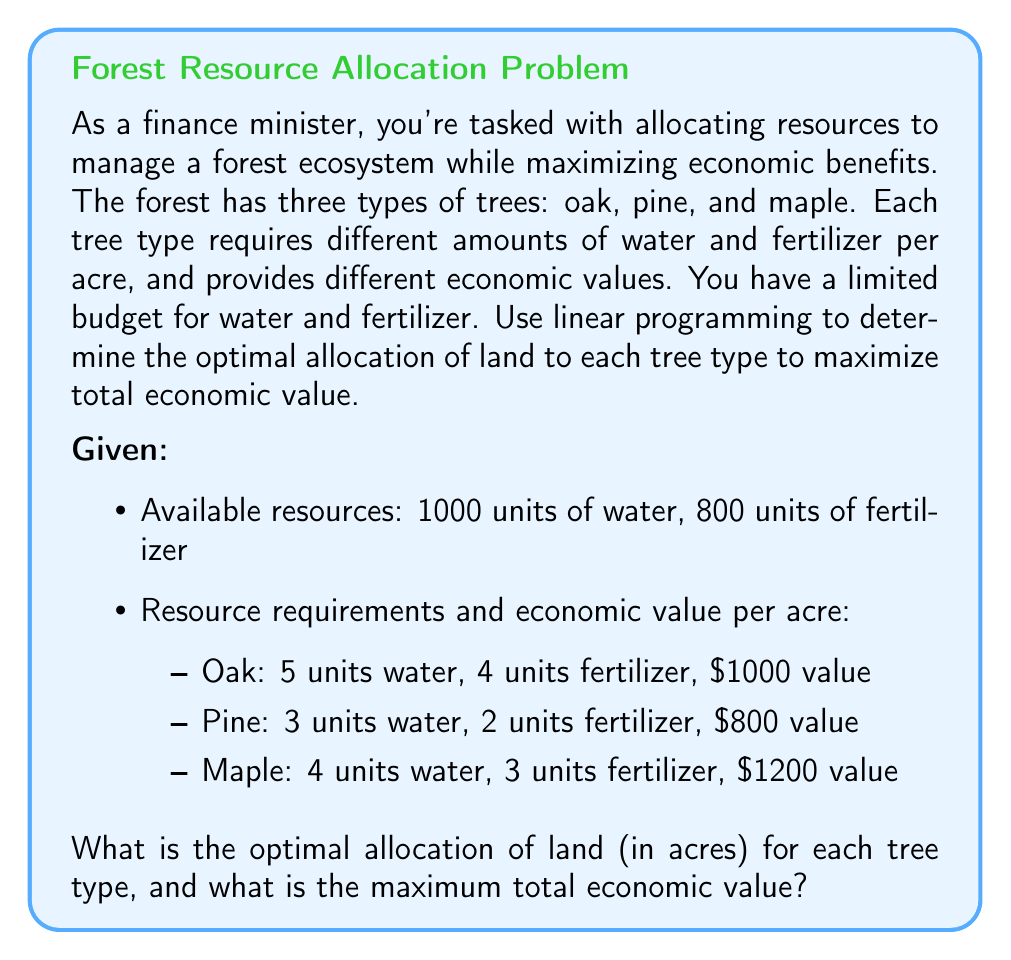Give your solution to this math problem. To solve this linear programming problem, we'll use the simplex method. Let's define our variables and set up the problem:

Let $x$ = acres of oak, $y$ = acres of pine, and $z$ = acres of maple.

Objective function (maximize total value):
$$\text{Max } 1000x + 800y + 1200z$$

Constraints:
1. Water: $5x + 3y + 4z \leq 1000$
2. Fertilizer: $4x + 2y + 3z \leq 800$
3. Non-negativity: $x, y, z \geq 0$

Now, let's solve using the simplex method:

1. Convert to standard form by adding slack variables:
   $$5x + 3y + 4z + s_1 = 1000$$
   $$4x + 2y + 3z + s_2 = 800$$

2. Initial tableau:
   $$\begin{array}{c|cccccc}
     & x & y & z & s_1 & s_2 & \text{RHS} \\
   \hline
   s_1 & 5 & 3 & 4 & 1 & 0 & 1000 \\
   s_2 & 4 & 2 & 3 & 0 & 1 & 800 \\
   \hline
   -Z & -1000 & -800 & -1200 & 0 & 0 & 0
   \end{array}$$

3. Pivot on the most negative entry in the bottom row (z column):
   $$\begin{array}{c|cccccc}
     & x & y & z & s_1 & s_2 & \text{RHS} \\
   \hline
   z & 5/4 & 3/4 & 1 & 1/4 & 0 & 250 \\
   s_2 & 1/4 & -1/4 & 0 & -3/4 & 1 & 50 \\
   \hline
   -Z & 500 & 100 & 0 & 300 & 0 & 300000
   \end{array}$$

4. Pivot on the most negative entry in the bottom row (y column):
   $$\begin{array}{c|cccccc}
     & x & y & z & s_1 & s_2 & \text{RHS} \\
   \hline
   z & 5/3 & 0 & 1 & 1/3 & -1 & 200 \\
   y & -1 & 1 & 0 & 3 & -4 & 200 \\
   \hline
   -Z & 600 & 0 & 0 & 400 & 400 & 320000
   \end{array}$$

5. The tableau is optimal as there are no negative entries in the bottom row.

6. Reading the solution:
   $z$ (maple) = 200 acres
   $y$ (pine) = 200 acres
   $x$ (oak) = 0 acres
   Maximum value = $320,000
Answer: Optimal allocation:
Oak: 0 acres
Pine: 200 acres
Maple: 200 acres
Maximum total economic value: $320,000 